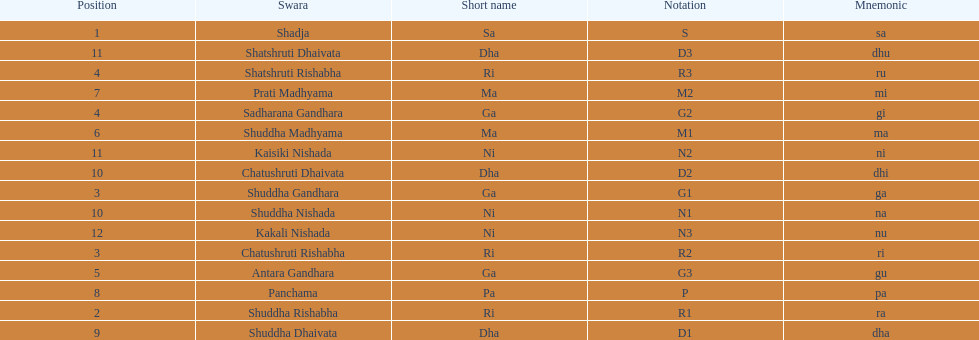Which swara follows immediately after antara gandhara? Shuddha Madhyama. 